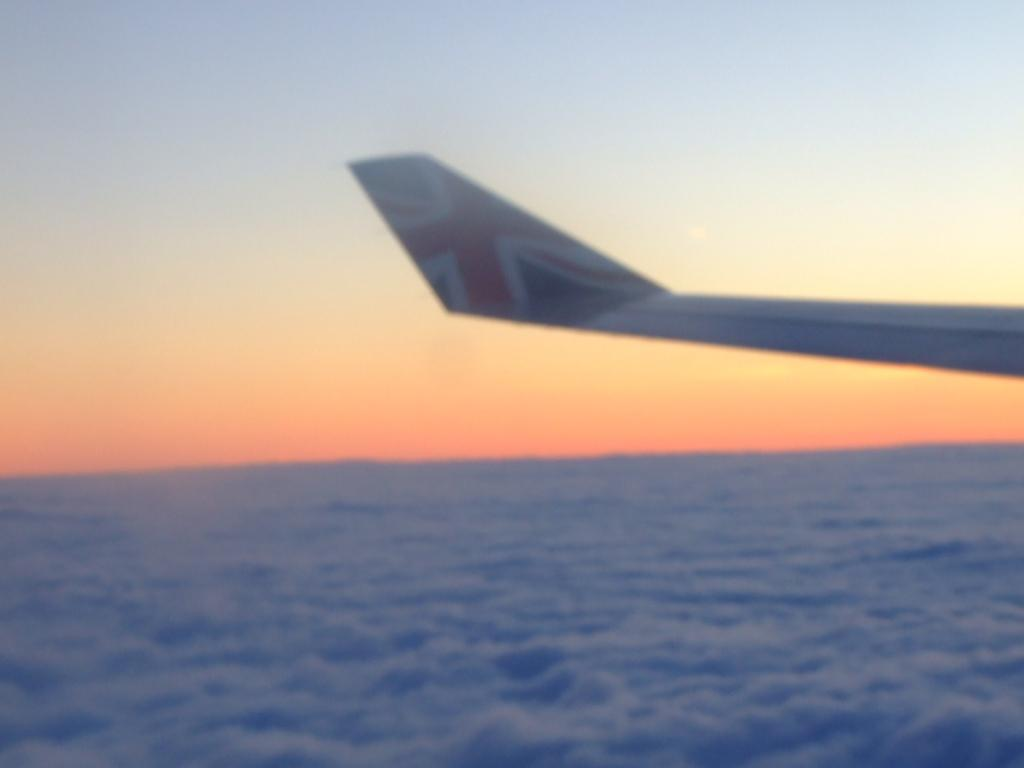What is the main subject of the image? The main subject of the image is an airplane. What can be seen at the bottom of the image? There is water at the bottom of the image. What is visible at the top of the image? The sky is visible at the top of the image. What type of adjustment can be seen on the airplane's wings in the image? There is no specific adjustment visible on the airplane's wings in the image. What kind of support is provided for the airplane in the image? The image does not show any support for the airplane; it appears to be flying. 